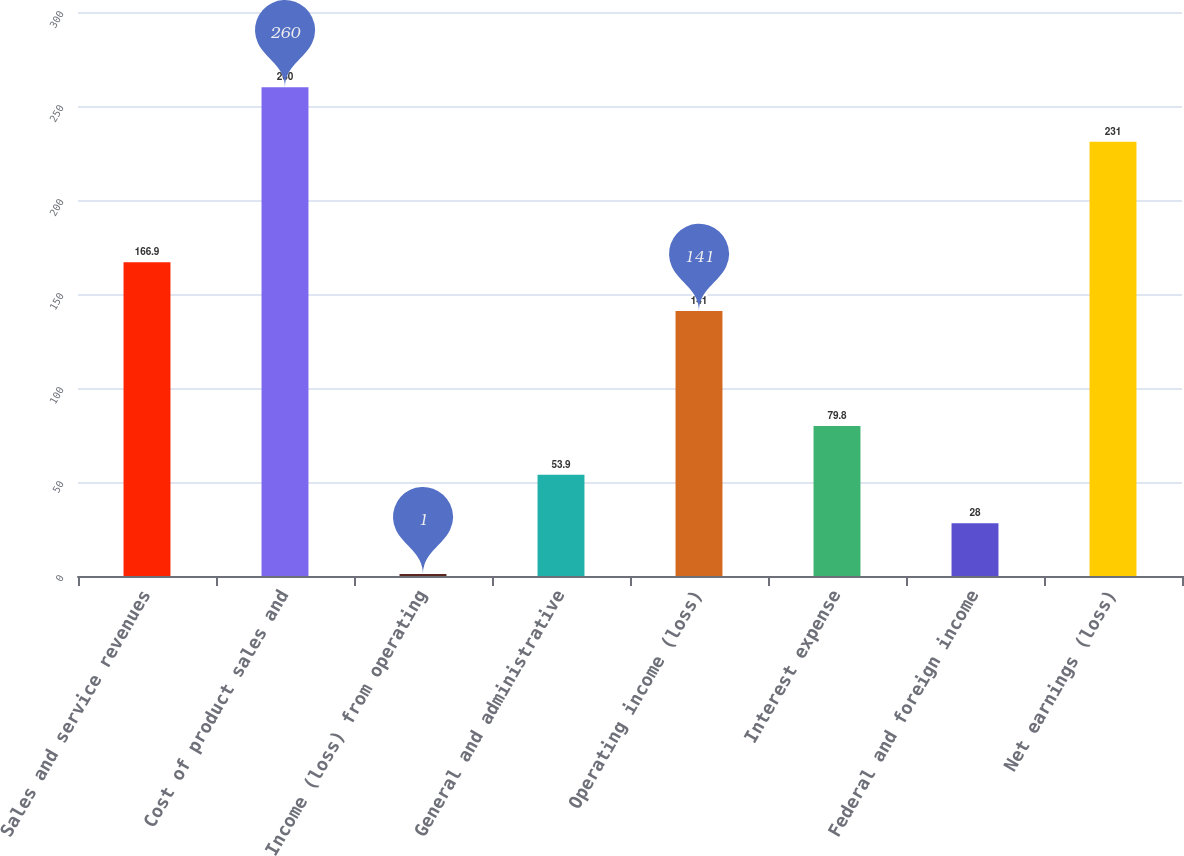Convert chart. <chart><loc_0><loc_0><loc_500><loc_500><bar_chart><fcel>Sales and service revenues<fcel>Cost of product sales and<fcel>Income (loss) from operating<fcel>General and administrative<fcel>Operating income (loss)<fcel>Interest expense<fcel>Federal and foreign income<fcel>Net earnings (loss)<nl><fcel>166.9<fcel>260<fcel>1<fcel>53.9<fcel>141<fcel>79.8<fcel>28<fcel>231<nl></chart> 